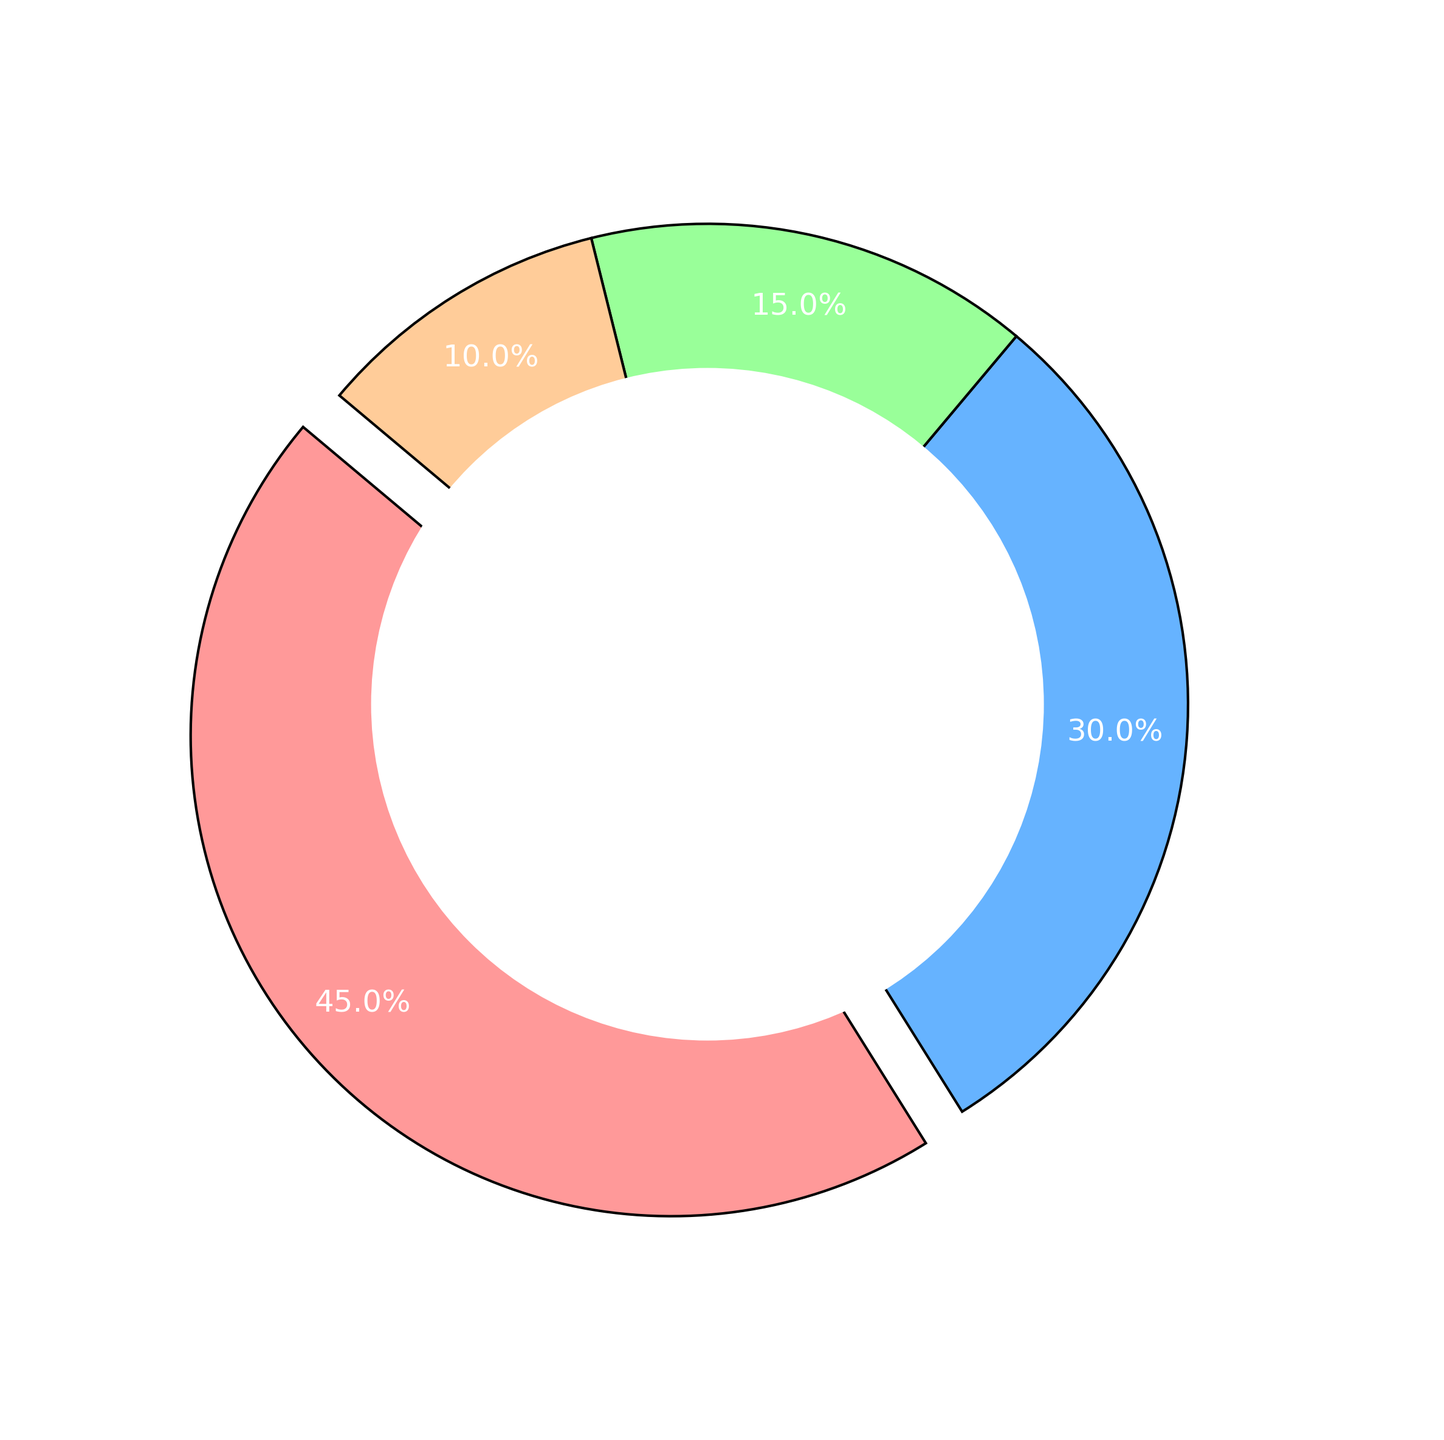What's the largest segment in the pie chart? The largest segment in the pie chart is the one which visually appears the biggest and takes up the most space. The segment labeled "Engine Problems" has the biggest size in the chart.
Answer: Engine Problems Which segment is visually exploded from the pie chart? The segment that appears to be separated slightly or "exploded" from the rest of the pie chart is usually indicated by a visual gap. In this chart, it's the "Engine Problems" segment.
Answer: Engine Problems What percentage of the total issues is attributed to Electrical Failures? From the pie chart, each segment is annotated with its percentage share of the total. The segment labeled "Electrical Failures" is marked with 15.0%.
Answer: 15.0% How many more issues are reported for Brake Issues compared to Other issues? To determine this, subtract the count for "Other" issues (10) from the count for "Brake Issues" (30): 30 - 10 = 20.
Answer: 20 What two segments together make up 55% of the total issues? By looking at the pie chart, we see that "Brake Issues" and "Electrical Failures" together make up 30.0% and 15.0% respectively, totaling 30.0% + 15.0% = 45.0%. Adding "Other" (10.0%) to this reaches 55.0%.
Answer: Brake Issues and Electrical Failures What is the ratio of Engine Problems to the sum of Electrical Failures and Other issues? "Engine Problems" have 45 issues, while "Electrical Failures" and "Other" together are 15 + 10 = 25 issues. The ratio is 45:25, which can be simplified to 9:5.
Answer: 9:5 How does the number of Electrical Failures compare to Other issues? By comparing the segments, you can see that there are 15 Electrical Failures and 10 Other issues. Since 15 is greater than 10, Electrical Failures occur more frequently than Other issues.
Answer: Electrical Failures are greater What fraction of the total issues is Engine Problems? Engine Problems account for 45 out of a total of (45 + 30 + 15 + 10) = 100 reported issues. The fraction is 45/100, which simplifies to 9/20.
Answer: 9/20 What is the combined percentage of Brake Issues and Electrical Failures? From the pie chart, Brake Issues represent 30.0% and Electrical Failures represent 15.0%. Adding these together, 30.0% + 15.0% = 45.0%.
Answer: 45.0% What portion of the issues is not Engine Problems? Engine Problems make up 45.0% of the total; thus, the remainder is 100% - 45.0% = 55.0%.
Answer: 55.0% 